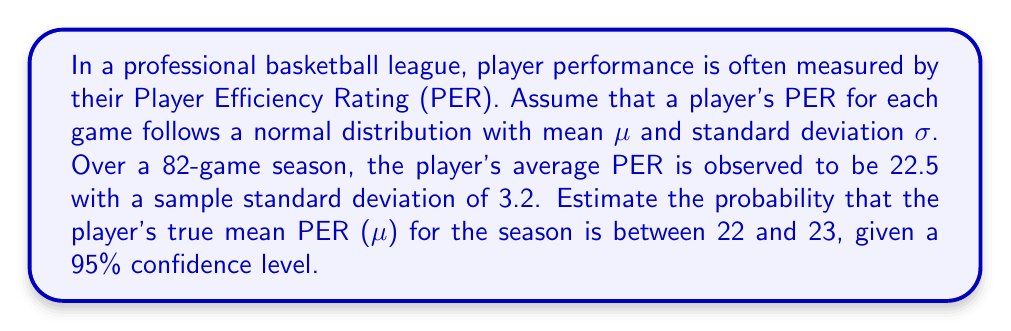Can you solve this math problem? Let's approach this step-by-step:

1) We are dealing with a normal distribution of PER scores. We know:
   - Sample mean ($\bar{x}$) = 22.5
   - Sample standard deviation (s) = 3.2
   - Number of games (n) = 82
   - Confidence level = 95% (α = 0.05)

2) The standard error of the mean (SEM) is:
   $$ SEM = \frac{s}{\sqrt{n}} = \frac{3.2}{\sqrt{82}} \approx 0.3535 $$

3) For a 95% confidence level, we use a z-score of 1.96 (from the standard normal distribution table).

4) The 95% confidence interval for the true mean is:
   $$ \bar{x} \pm (z \times SEM) = 22.5 \pm (1.96 \times 0.3535) $$
   $$ = 22.5 \pm 0.6929 = (21.8071, 23.1929) $$

5) We want to find P(22 < μ < 23). We can standardize these bounds:
   $$ z_{lower} = \frac{22 - 22.5}{0.3535} \approx -1.4144 $$
   $$ z_{upper} = \frac{23 - 22.5}{0.3535} \approx 1.4144 $$

6) The probability is the area between these z-scores in a standard normal distribution:
   $$ P(22 < \mu < 23) = \Phi(1.4144) - \Phi(-1.4144) $$
   where Φ is the cumulative distribution function of the standard normal distribution.

7) Using a standard normal table or calculator:
   $$ P(22 < \mu < 23) = 0.9214 - 0.0786 = 0.8428 $$

Therefore, there is approximately an 84.28% chance that the player's true mean PER for the season is between 22 and 23.
Answer: 0.8428 or 84.28% 